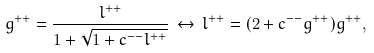Convert formula to latex. <formula><loc_0><loc_0><loc_500><loc_500>g ^ { + + } = \frac { l ^ { + + } } { 1 + \sqrt { 1 + c ^ { - - } l ^ { + + } } } \, \leftrightarrow \, l ^ { + + } = ( 2 + c ^ { - - } g ^ { + + } ) g ^ { + + } ,</formula> 